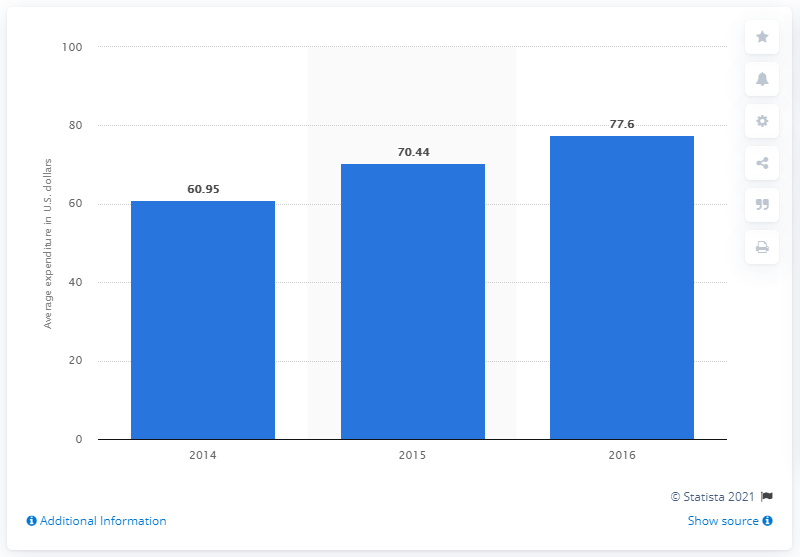Indicate a few pertinent items in this graphic. During the last reported period, the average overall mobile gaming expenditure per user was 77.6. 